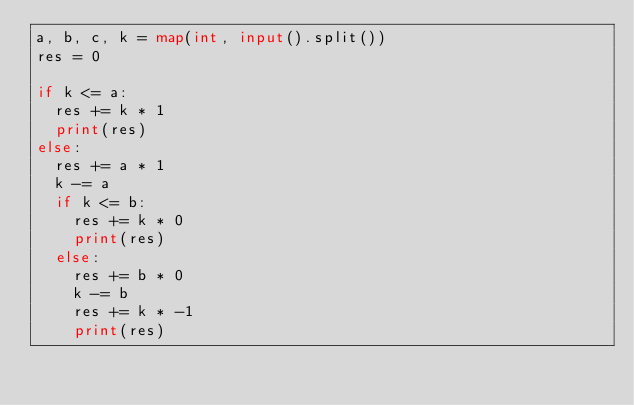Convert code to text. <code><loc_0><loc_0><loc_500><loc_500><_Python_>a, b, c, k = map(int, input().split())
res = 0

if k <= a:
  res += k * 1
  print(res)
else:
  res += a * 1
  k -= a
  if k <= b:
    res += k * 0
    print(res)
  else:
    res += b * 0
    k -= b
    res += k * -1
    print(res)
    </code> 